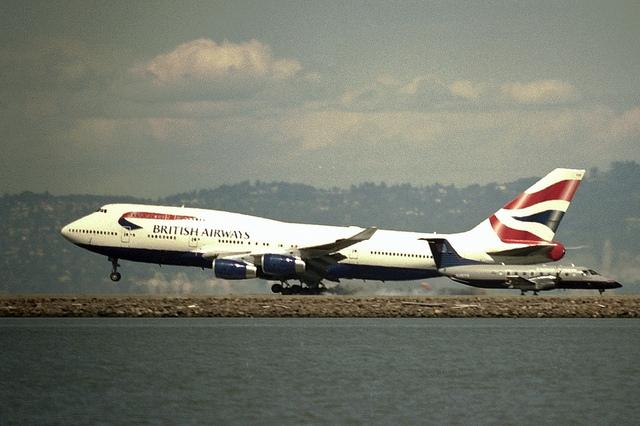Where is this plane from?
Concise answer only. Britain. Is this plane landing?
Give a very brief answer. Yes. What is written on the side of the plane?
Concise answer only. British airways. Is the plane in motion?
Write a very short answer. Yes. How many people can fit in this plane?
Be succinct. 300. Is this a turboprop airplane?
Write a very short answer. Yes. Is the plane parked?
Answer briefly. No. 